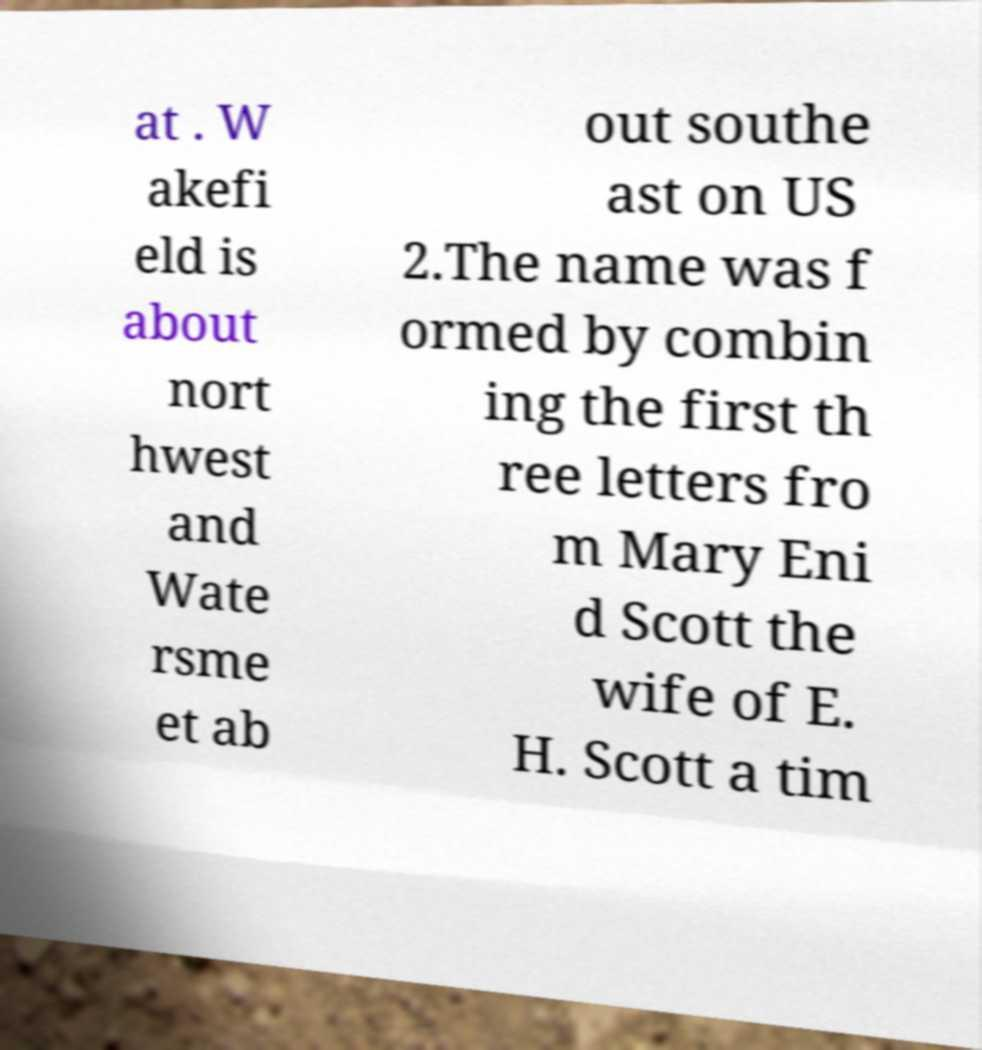I need the written content from this picture converted into text. Can you do that? at . W akefi eld is about nort hwest and Wate rsme et ab out southe ast on US 2.The name was f ormed by combin ing the first th ree letters fro m Mary Eni d Scott the wife of E. H. Scott a tim 